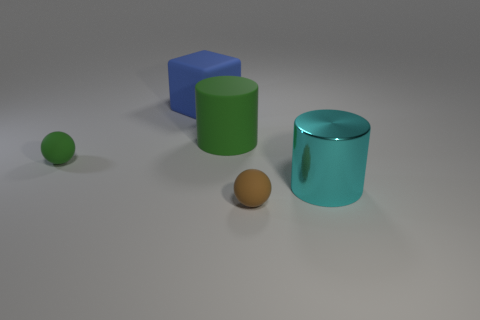Add 5 blue matte cubes. How many objects exist? 10 Subtract all cylinders. How many objects are left? 3 Subtract 1 cylinders. How many cylinders are left? 1 Add 1 large brown shiny blocks. How many large brown shiny blocks exist? 1 Subtract 0 purple blocks. How many objects are left? 5 Subtract all purple cylinders. Subtract all cyan spheres. How many cylinders are left? 2 Subtract all red blocks. Subtract all big green rubber things. How many objects are left? 4 Add 5 big things. How many big things are left? 8 